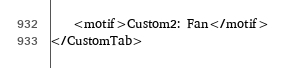Convert code to text. <code><loc_0><loc_0><loc_500><loc_500><_SQL_>    <motif>Custom2: Fan</motif>
</CustomTab>
</code> 